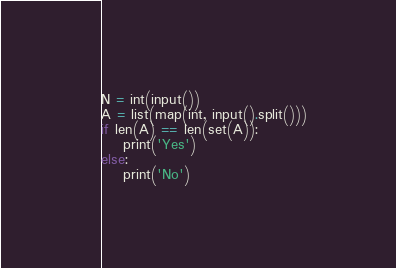<code> <loc_0><loc_0><loc_500><loc_500><_Python_>N = int(input())
A = list(map(int, input().split()))
if len(A) == len(set(A)):
    print('Yes')
else:
    print('No')
</code> 